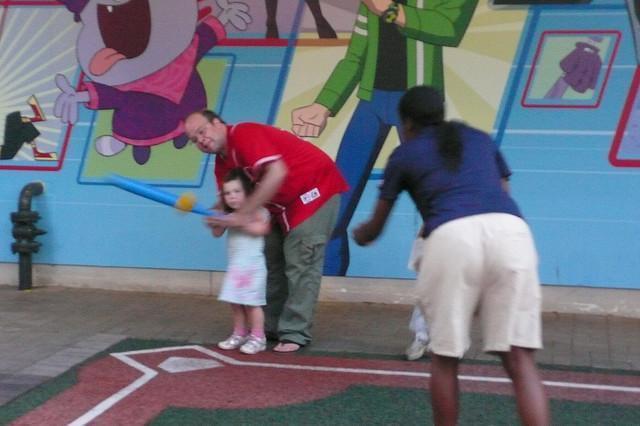How many people can you see?
Give a very brief answer. 3. How many cats are on the top shelf?
Give a very brief answer. 0. 